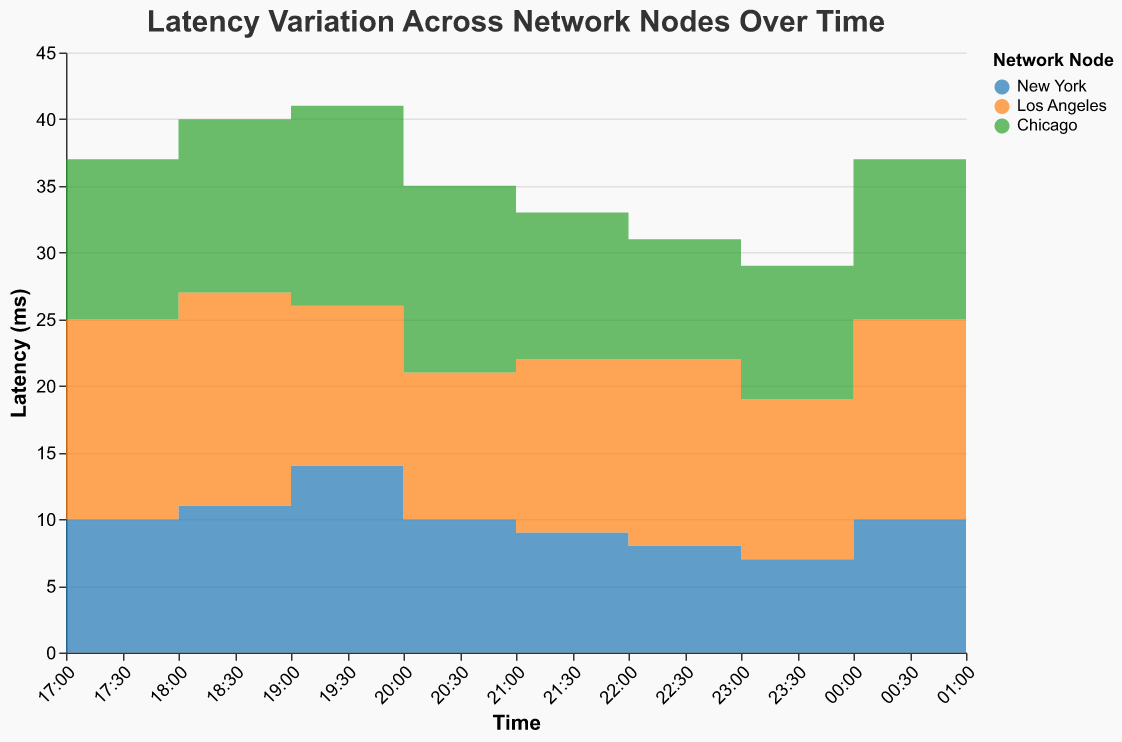What is the title of the figure? The title of the figure is prominently displayed at the top in a larger font size, reading "Latency Variation Across Network Nodes Over Time".
Answer: Latency Variation Across Network Nodes Over Time What are the colors used to represent each network node? Each node is assigned a distinct color. New York is blue, Los Angeles is orange, and Chicago is green.
Answer: New York (blue), Los Angeles (orange), Chicago (green) Which timestamp has the highest latency for the New York node? By checking the step areas for the New York node and identifying the highest point, it can be observed that the highest latency is 14 ms, occurring at 2023-10-01T02:00:00Z.
Answer: 2023-10-01T02:00:00Z Between 2023-10-01T03:00:00Z and 2023-10-01T07:00:00Z, which node shows the most significant decrease in latency? By examining the step areas, we can see that for the Los Angeles node, the latency drops from 15 ms at 2023-10-01T07:00:00Z to 11 ms at 2023-10-01T03:00:00Z, which is the largest decrease compared to other nodes.
Answer: Los Angeles What is the average latency for the Chicago node over the entire time range? Sum up all latency values for the Chicago node and divide by the number of timestamps. (12 + 13 + 15 + 14 + 11 + 9 + 10 + 12 + 13) / 9 = 109 / 9 ≈ 12.11 ms
Answer: 12.11 ms Which node has the lowest average latency and what is it? Calculate the average latency for each node and compare. For New York: (10+11+14+10+9+8+7+10+11)/9 = 9.89 ms; For Los Angeles: (15+16+12+11+13+14+12+15+16)/9 = 13.78 ms; For Chicago: 12.11 ms. The lowest average is for New York.
Answer: New York, 9.89 ms At which timestamp does Chicago experience its lowest latency? Reviewing the plot, the lowest point for Chicago is 9 ms at timestamp 2023-10-01T05:00:00Z.
Answer: 2023-10-01T05:00:00Z How does the latency trend for Los Angeles change from 2023-10-01T06:00:00Z to 2023-10-01T08:00:00Z? Looking at the plot, latency for Los Angeles increases from 12 ms at 2023-10-01T06:00:00Z to 15 ms at 2023-10-01T07:00:00Z and further to 16 ms at 2023-10-01T08:00:00Z.
Answer: Increases Which node has the highest variability in latency? Considering the range of latencies: New York (7-14 ms), Los Angeles (11-16 ms), Chicago (9-15 ms). Los Angeles has the widest range, indicating the highest variability.
Answer: Los Angeles 